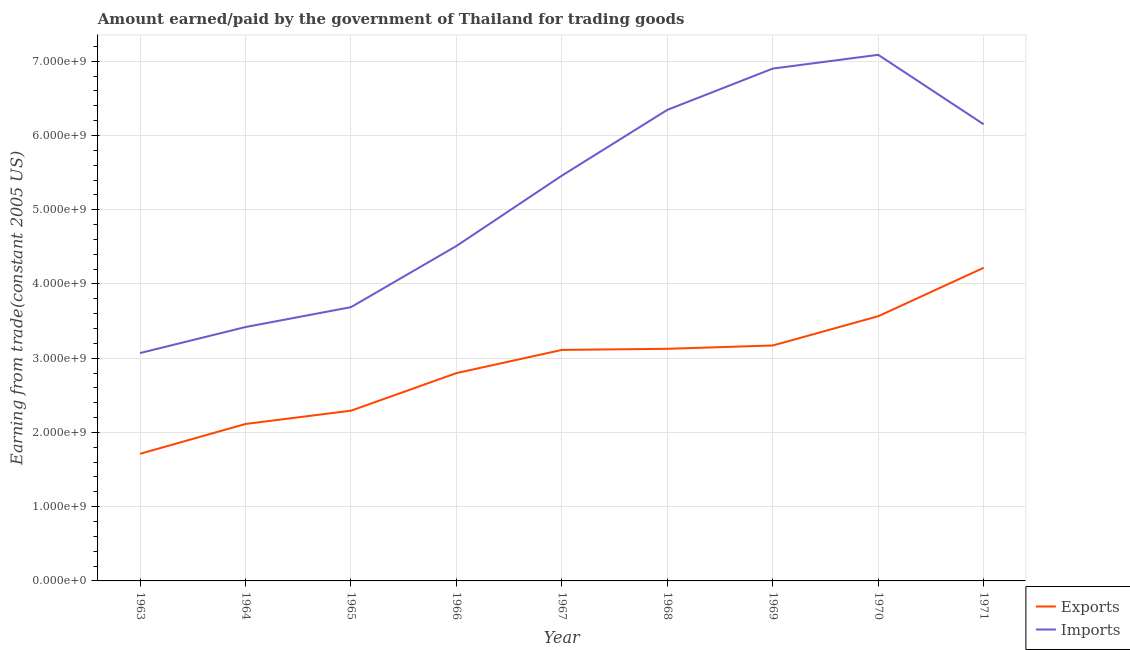Does the line corresponding to amount paid for imports intersect with the line corresponding to amount earned from exports?
Ensure brevity in your answer.  No. What is the amount earned from exports in 1967?
Offer a very short reply. 3.11e+09. Across all years, what is the maximum amount paid for imports?
Make the answer very short. 7.09e+09. Across all years, what is the minimum amount earned from exports?
Your answer should be compact. 1.71e+09. What is the total amount earned from exports in the graph?
Offer a terse response. 2.61e+1. What is the difference between the amount paid for imports in 1965 and that in 1969?
Your response must be concise. -3.21e+09. What is the difference between the amount paid for imports in 1966 and the amount earned from exports in 1969?
Provide a succinct answer. 1.34e+09. What is the average amount earned from exports per year?
Your answer should be very brief. 2.90e+09. In the year 1963, what is the difference between the amount paid for imports and amount earned from exports?
Offer a terse response. 1.36e+09. In how many years, is the amount paid for imports greater than 1800000000 US$?
Offer a terse response. 9. What is the ratio of the amount earned from exports in 1964 to that in 1970?
Give a very brief answer. 0.59. Is the amount paid for imports in 1966 less than that in 1970?
Provide a short and direct response. Yes. What is the difference between the highest and the second highest amount earned from exports?
Your answer should be compact. 6.53e+08. What is the difference between the highest and the lowest amount earned from exports?
Give a very brief answer. 2.51e+09. In how many years, is the amount earned from exports greater than the average amount earned from exports taken over all years?
Your answer should be very brief. 5. Does the amount paid for imports monotonically increase over the years?
Offer a terse response. No. What is the difference between two consecutive major ticks on the Y-axis?
Provide a short and direct response. 1.00e+09. Are the values on the major ticks of Y-axis written in scientific E-notation?
Your answer should be very brief. Yes. Does the graph contain any zero values?
Make the answer very short. No. Where does the legend appear in the graph?
Keep it short and to the point. Bottom right. What is the title of the graph?
Your answer should be compact. Amount earned/paid by the government of Thailand for trading goods. What is the label or title of the X-axis?
Your answer should be compact. Year. What is the label or title of the Y-axis?
Your answer should be very brief. Earning from trade(constant 2005 US). What is the Earning from trade(constant 2005 US) in Exports in 1963?
Your response must be concise. 1.71e+09. What is the Earning from trade(constant 2005 US) of Imports in 1963?
Your response must be concise. 3.07e+09. What is the Earning from trade(constant 2005 US) of Exports in 1964?
Your answer should be very brief. 2.11e+09. What is the Earning from trade(constant 2005 US) of Imports in 1964?
Your response must be concise. 3.42e+09. What is the Earning from trade(constant 2005 US) in Exports in 1965?
Keep it short and to the point. 2.29e+09. What is the Earning from trade(constant 2005 US) of Imports in 1965?
Make the answer very short. 3.69e+09. What is the Earning from trade(constant 2005 US) in Exports in 1966?
Give a very brief answer. 2.80e+09. What is the Earning from trade(constant 2005 US) in Imports in 1966?
Offer a terse response. 4.51e+09. What is the Earning from trade(constant 2005 US) in Exports in 1967?
Make the answer very short. 3.11e+09. What is the Earning from trade(constant 2005 US) of Imports in 1967?
Give a very brief answer. 5.46e+09. What is the Earning from trade(constant 2005 US) of Exports in 1968?
Ensure brevity in your answer.  3.13e+09. What is the Earning from trade(constant 2005 US) of Imports in 1968?
Offer a terse response. 6.34e+09. What is the Earning from trade(constant 2005 US) in Exports in 1969?
Give a very brief answer. 3.17e+09. What is the Earning from trade(constant 2005 US) in Imports in 1969?
Your answer should be compact. 6.90e+09. What is the Earning from trade(constant 2005 US) in Exports in 1970?
Your answer should be compact. 3.57e+09. What is the Earning from trade(constant 2005 US) of Imports in 1970?
Keep it short and to the point. 7.09e+09. What is the Earning from trade(constant 2005 US) of Exports in 1971?
Provide a short and direct response. 4.22e+09. What is the Earning from trade(constant 2005 US) of Imports in 1971?
Your response must be concise. 6.15e+09. Across all years, what is the maximum Earning from trade(constant 2005 US) of Exports?
Your answer should be compact. 4.22e+09. Across all years, what is the maximum Earning from trade(constant 2005 US) in Imports?
Offer a terse response. 7.09e+09. Across all years, what is the minimum Earning from trade(constant 2005 US) in Exports?
Your response must be concise. 1.71e+09. Across all years, what is the minimum Earning from trade(constant 2005 US) in Imports?
Your answer should be very brief. 3.07e+09. What is the total Earning from trade(constant 2005 US) of Exports in the graph?
Give a very brief answer. 2.61e+1. What is the total Earning from trade(constant 2005 US) in Imports in the graph?
Your answer should be very brief. 4.66e+1. What is the difference between the Earning from trade(constant 2005 US) in Exports in 1963 and that in 1964?
Make the answer very short. -4.02e+08. What is the difference between the Earning from trade(constant 2005 US) in Imports in 1963 and that in 1964?
Provide a succinct answer. -3.50e+08. What is the difference between the Earning from trade(constant 2005 US) in Exports in 1963 and that in 1965?
Give a very brief answer. -5.81e+08. What is the difference between the Earning from trade(constant 2005 US) of Imports in 1963 and that in 1965?
Your answer should be very brief. -6.18e+08. What is the difference between the Earning from trade(constant 2005 US) in Exports in 1963 and that in 1966?
Provide a short and direct response. -1.09e+09. What is the difference between the Earning from trade(constant 2005 US) in Imports in 1963 and that in 1966?
Offer a terse response. -1.44e+09. What is the difference between the Earning from trade(constant 2005 US) of Exports in 1963 and that in 1967?
Make the answer very short. -1.40e+09. What is the difference between the Earning from trade(constant 2005 US) in Imports in 1963 and that in 1967?
Provide a succinct answer. -2.39e+09. What is the difference between the Earning from trade(constant 2005 US) in Exports in 1963 and that in 1968?
Give a very brief answer. -1.41e+09. What is the difference between the Earning from trade(constant 2005 US) in Imports in 1963 and that in 1968?
Your answer should be very brief. -3.28e+09. What is the difference between the Earning from trade(constant 2005 US) of Exports in 1963 and that in 1969?
Make the answer very short. -1.46e+09. What is the difference between the Earning from trade(constant 2005 US) of Imports in 1963 and that in 1969?
Your response must be concise. -3.83e+09. What is the difference between the Earning from trade(constant 2005 US) of Exports in 1963 and that in 1970?
Offer a terse response. -1.85e+09. What is the difference between the Earning from trade(constant 2005 US) in Imports in 1963 and that in 1970?
Provide a short and direct response. -4.02e+09. What is the difference between the Earning from trade(constant 2005 US) in Exports in 1963 and that in 1971?
Provide a succinct answer. -2.51e+09. What is the difference between the Earning from trade(constant 2005 US) in Imports in 1963 and that in 1971?
Offer a very short reply. -3.08e+09. What is the difference between the Earning from trade(constant 2005 US) of Exports in 1964 and that in 1965?
Ensure brevity in your answer.  -1.79e+08. What is the difference between the Earning from trade(constant 2005 US) in Imports in 1964 and that in 1965?
Offer a very short reply. -2.68e+08. What is the difference between the Earning from trade(constant 2005 US) in Exports in 1964 and that in 1966?
Give a very brief answer. -6.85e+08. What is the difference between the Earning from trade(constant 2005 US) of Imports in 1964 and that in 1966?
Provide a succinct answer. -1.09e+09. What is the difference between the Earning from trade(constant 2005 US) of Exports in 1964 and that in 1967?
Your answer should be compact. -9.98e+08. What is the difference between the Earning from trade(constant 2005 US) in Imports in 1964 and that in 1967?
Provide a short and direct response. -2.04e+09. What is the difference between the Earning from trade(constant 2005 US) in Exports in 1964 and that in 1968?
Offer a very short reply. -1.01e+09. What is the difference between the Earning from trade(constant 2005 US) of Imports in 1964 and that in 1968?
Your answer should be compact. -2.93e+09. What is the difference between the Earning from trade(constant 2005 US) of Exports in 1964 and that in 1969?
Keep it short and to the point. -1.06e+09. What is the difference between the Earning from trade(constant 2005 US) of Imports in 1964 and that in 1969?
Your response must be concise. -3.48e+09. What is the difference between the Earning from trade(constant 2005 US) in Exports in 1964 and that in 1970?
Offer a terse response. -1.45e+09. What is the difference between the Earning from trade(constant 2005 US) in Imports in 1964 and that in 1970?
Ensure brevity in your answer.  -3.67e+09. What is the difference between the Earning from trade(constant 2005 US) in Exports in 1964 and that in 1971?
Your answer should be very brief. -2.10e+09. What is the difference between the Earning from trade(constant 2005 US) in Imports in 1964 and that in 1971?
Give a very brief answer. -2.73e+09. What is the difference between the Earning from trade(constant 2005 US) of Exports in 1965 and that in 1966?
Provide a succinct answer. -5.06e+08. What is the difference between the Earning from trade(constant 2005 US) of Imports in 1965 and that in 1966?
Your answer should be very brief. -8.24e+08. What is the difference between the Earning from trade(constant 2005 US) in Exports in 1965 and that in 1967?
Provide a short and direct response. -8.19e+08. What is the difference between the Earning from trade(constant 2005 US) of Imports in 1965 and that in 1967?
Your answer should be very brief. -1.77e+09. What is the difference between the Earning from trade(constant 2005 US) of Exports in 1965 and that in 1968?
Your answer should be compact. -8.34e+08. What is the difference between the Earning from trade(constant 2005 US) in Imports in 1965 and that in 1968?
Your answer should be compact. -2.66e+09. What is the difference between the Earning from trade(constant 2005 US) of Exports in 1965 and that in 1969?
Keep it short and to the point. -8.78e+08. What is the difference between the Earning from trade(constant 2005 US) of Imports in 1965 and that in 1969?
Your response must be concise. -3.21e+09. What is the difference between the Earning from trade(constant 2005 US) of Exports in 1965 and that in 1970?
Your answer should be compact. -1.27e+09. What is the difference between the Earning from trade(constant 2005 US) in Imports in 1965 and that in 1970?
Your answer should be compact. -3.40e+09. What is the difference between the Earning from trade(constant 2005 US) of Exports in 1965 and that in 1971?
Offer a very short reply. -1.93e+09. What is the difference between the Earning from trade(constant 2005 US) in Imports in 1965 and that in 1971?
Your answer should be compact. -2.46e+09. What is the difference between the Earning from trade(constant 2005 US) of Exports in 1966 and that in 1967?
Offer a very short reply. -3.13e+08. What is the difference between the Earning from trade(constant 2005 US) of Imports in 1966 and that in 1967?
Your response must be concise. -9.48e+08. What is the difference between the Earning from trade(constant 2005 US) of Exports in 1966 and that in 1968?
Your answer should be compact. -3.28e+08. What is the difference between the Earning from trade(constant 2005 US) of Imports in 1966 and that in 1968?
Your answer should be very brief. -1.83e+09. What is the difference between the Earning from trade(constant 2005 US) of Exports in 1966 and that in 1969?
Provide a succinct answer. -3.72e+08. What is the difference between the Earning from trade(constant 2005 US) in Imports in 1966 and that in 1969?
Give a very brief answer. -2.39e+09. What is the difference between the Earning from trade(constant 2005 US) of Exports in 1966 and that in 1970?
Make the answer very short. -7.67e+08. What is the difference between the Earning from trade(constant 2005 US) of Imports in 1966 and that in 1970?
Ensure brevity in your answer.  -2.57e+09. What is the difference between the Earning from trade(constant 2005 US) in Exports in 1966 and that in 1971?
Keep it short and to the point. -1.42e+09. What is the difference between the Earning from trade(constant 2005 US) of Imports in 1966 and that in 1971?
Your response must be concise. -1.64e+09. What is the difference between the Earning from trade(constant 2005 US) of Exports in 1967 and that in 1968?
Make the answer very short. -1.49e+07. What is the difference between the Earning from trade(constant 2005 US) in Imports in 1967 and that in 1968?
Provide a short and direct response. -8.86e+08. What is the difference between the Earning from trade(constant 2005 US) in Exports in 1967 and that in 1969?
Provide a succinct answer. -5.95e+07. What is the difference between the Earning from trade(constant 2005 US) in Imports in 1967 and that in 1969?
Your response must be concise. -1.44e+09. What is the difference between the Earning from trade(constant 2005 US) in Exports in 1967 and that in 1970?
Offer a terse response. -4.54e+08. What is the difference between the Earning from trade(constant 2005 US) of Imports in 1967 and that in 1970?
Provide a succinct answer. -1.63e+09. What is the difference between the Earning from trade(constant 2005 US) of Exports in 1967 and that in 1971?
Ensure brevity in your answer.  -1.11e+09. What is the difference between the Earning from trade(constant 2005 US) of Imports in 1967 and that in 1971?
Offer a terse response. -6.91e+08. What is the difference between the Earning from trade(constant 2005 US) of Exports in 1968 and that in 1969?
Provide a short and direct response. -4.47e+07. What is the difference between the Earning from trade(constant 2005 US) of Imports in 1968 and that in 1969?
Offer a very short reply. -5.56e+08. What is the difference between the Earning from trade(constant 2005 US) in Exports in 1968 and that in 1970?
Your answer should be very brief. -4.39e+08. What is the difference between the Earning from trade(constant 2005 US) in Imports in 1968 and that in 1970?
Give a very brief answer. -7.41e+08. What is the difference between the Earning from trade(constant 2005 US) in Exports in 1968 and that in 1971?
Keep it short and to the point. -1.09e+09. What is the difference between the Earning from trade(constant 2005 US) of Imports in 1968 and that in 1971?
Your response must be concise. 1.95e+08. What is the difference between the Earning from trade(constant 2005 US) of Exports in 1969 and that in 1970?
Provide a short and direct response. -3.94e+08. What is the difference between the Earning from trade(constant 2005 US) in Imports in 1969 and that in 1970?
Provide a succinct answer. -1.85e+08. What is the difference between the Earning from trade(constant 2005 US) in Exports in 1969 and that in 1971?
Ensure brevity in your answer.  -1.05e+09. What is the difference between the Earning from trade(constant 2005 US) in Imports in 1969 and that in 1971?
Offer a terse response. 7.51e+08. What is the difference between the Earning from trade(constant 2005 US) in Exports in 1970 and that in 1971?
Your response must be concise. -6.53e+08. What is the difference between the Earning from trade(constant 2005 US) of Imports in 1970 and that in 1971?
Offer a very short reply. 9.36e+08. What is the difference between the Earning from trade(constant 2005 US) in Exports in 1963 and the Earning from trade(constant 2005 US) in Imports in 1964?
Give a very brief answer. -1.71e+09. What is the difference between the Earning from trade(constant 2005 US) of Exports in 1963 and the Earning from trade(constant 2005 US) of Imports in 1965?
Your answer should be compact. -1.98e+09. What is the difference between the Earning from trade(constant 2005 US) in Exports in 1963 and the Earning from trade(constant 2005 US) in Imports in 1966?
Your response must be concise. -2.80e+09. What is the difference between the Earning from trade(constant 2005 US) of Exports in 1963 and the Earning from trade(constant 2005 US) of Imports in 1967?
Provide a short and direct response. -3.75e+09. What is the difference between the Earning from trade(constant 2005 US) of Exports in 1963 and the Earning from trade(constant 2005 US) of Imports in 1968?
Offer a very short reply. -4.63e+09. What is the difference between the Earning from trade(constant 2005 US) in Exports in 1963 and the Earning from trade(constant 2005 US) in Imports in 1969?
Your answer should be very brief. -5.19e+09. What is the difference between the Earning from trade(constant 2005 US) in Exports in 1963 and the Earning from trade(constant 2005 US) in Imports in 1970?
Provide a short and direct response. -5.37e+09. What is the difference between the Earning from trade(constant 2005 US) in Exports in 1963 and the Earning from trade(constant 2005 US) in Imports in 1971?
Offer a terse response. -4.44e+09. What is the difference between the Earning from trade(constant 2005 US) in Exports in 1964 and the Earning from trade(constant 2005 US) in Imports in 1965?
Your response must be concise. -1.57e+09. What is the difference between the Earning from trade(constant 2005 US) of Exports in 1964 and the Earning from trade(constant 2005 US) of Imports in 1966?
Your response must be concise. -2.40e+09. What is the difference between the Earning from trade(constant 2005 US) in Exports in 1964 and the Earning from trade(constant 2005 US) in Imports in 1967?
Provide a short and direct response. -3.34e+09. What is the difference between the Earning from trade(constant 2005 US) of Exports in 1964 and the Earning from trade(constant 2005 US) of Imports in 1968?
Offer a very short reply. -4.23e+09. What is the difference between the Earning from trade(constant 2005 US) in Exports in 1964 and the Earning from trade(constant 2005 US) in Imports in 1969?
Keep it short and to the point. -4.79e+09. What is the difference between the Earning from trade(constant 2005 US) of Exports in 1964 and the Earning from trade(constant 2005 US) of Imports in 1970?
Ensure brevity in your answer.  -4.97e+09. What is the difference between the Earning from trade(constant 2005 US) in Exports in 1964 and the Earning from trade(constant 2005 US) in Imports in 1971?
Make the answer very short. -4.04e+09. What is the difference between the Earning from trade(constant 2005 US) in Exports in 1965 and the Earning from trade(constant 2005 US) in Imports in 1966?
Your answer should be compact. -2.22e+09. What is the difference between the Earning from trade(constant 2005 US) in Exports in 1965 and the Earning from trade(constant 2005 US) in Imports in 1967?
Offer a terse response. -3.17e+09. What is the difference between the Earning from trade(constant 2005 US) in Exports in 1965 and the Earning from trade(constant 2005 US) in Imports in 1968?
Give a very brief answer. -4.05e+09. What is the difference between the Earning from trade(constant 2005 US) of Exports in 1965 and the Earning from trade(constant 2005 US) of Imports in 1969?
Your answer should be compact. -4.61e+09. What is the difference between the Earning from trade(constant 2005 US) in Exports in 1965 and the Earning from trade(constant 2005 US) in Imports in 1970?
Make the answer very short. -4.79e+09. What is the difference between the Earning from trade(constant 2005 US) of Exports in 1965 and the Earning from trade(constant 2005 US) of Imports in 1971?
Your answer should be compact. -3.86e+09. What is the difference between the Earning from trade(constant 2005 US) of Exports in 1966 and the Earning from trade(constant 2005 US) of Imports in 1967?
Make the answer very short. -2.66e+09. What is the difference between the Earning from trade(constant 2005 US) of Exports in 1966 and the Earning from trade(constant 2005 US) of Imports in 1968?
Ensure brevity in your answer.  -3.55e+09. What is the difference between the Earning from trade(constant 2005 US) of Exports in 1966 and the Earning from trade(constant 2005 US) of Imports in 1969?
Ensure brevity in your answer.  -4.10e+09. What is the difference between the Earning from trade(constant 2005 US) in Exports in 1966 and the Earning from trade(constant 2005 US) in Imports in 1970?
Your answer should be compact. -4.29e+09. What is the difference between the Earning from trade(constant 2005 US) in Exports in 1966 and the Earning from trade(constant 2005 US) in Imports in 1971?
Ensure brevity in your answer.  -3.35e+09. What is the difference between the Earning from trade(constant 2005 US) in Exports in 1967 and the Earning from trade(constant 2005 US) in Imports in 1968?
Ensure brevity in your answer.  -3.23e+09. What is the difference between the Earning from trade(constant 2005 US) in Exports in 1967 and the Earning from trade(constant 2005 US) in Imports in 1969?
Offer a very short reply. -3.79e+09. What is the difference between the Earning from trade(constant 2005 US) in Exports in 1967 and the Earning from trade(constant 2005 US) in Imports in 1970?
Your response must be concise. -3.97e+09. What is the difference between the Earning from trade(constant 2005 US) of Exports in 1967 and the Earning from trade(constant 2005 US) of Imports in 1971?
Your answer should be very brief. -3.04e+09. What is the difference between the Earning from trade(constant 2005 US) in Exports in 1968 and the Earning from trade(constant 2005 US) in Imports in 1969?
Make the answer very short. -3.77e+09. What is the difference between the Earning from trade(constant 2005 US) in Exports in 1968 and the Earning from trade(constant 2005 US) in Imports in 1970?
Keep it short and to the point. -3.96e+09. What is the difference between the Earning from trade(constant 2005 US) of Exports in 1968 and the Earning from trade(constant 2005 US) of Imports in 1971?
Offer a terse response. -3.02e+09. What is the difference between the Earning from trade(constant 2005 US) of Exports in 1969 and the Earning from trade(constant 2005 US) of Imports in 1970?
Make the answer very short. -3.92e+09. What is the difference between the Earning from trade(constant 2005 US) of Exports in 1969 and the Earning from trade(constant 2005 US) of Imports in 1971?
Your answer should be compact. -2.98e+09. What is the difference between the Earning from trade(constant 2005 US) in Exports in 1970 and the Earning from trade(constant 2005 US) in Imports in 1971?
Your response must be concise. -2.58e+09. What is the average Earning from trade(constant 2005 US) in Exports per year?
Give a very brief answer. 2.90e+09. What is the average Earning from trade(constant 2005 US) of Imports per year?
Make the answer very short. 5.18e+09. In the year 1963, what is the difference between the Earning from trade(constant 2005 US) in Exports and Earning from trade(constant 2005 US) in Imports?
Make the answer very short. -1.36e+09. In the year 1964, what is the difference between the Earning from trade(constant 2005 US) in Exports and Earning from trade(constant 2005 US) in Imports?
Your answer should be compact. -1.31e+09. In the year 1965, what is the difference between the Earning from trade(constant 2005 US) of Exports and Earning from trade(constant 2005 US) of Imports?
Make the answer very short. -1.39e+09. In the year 1966, what is the difference between the Earning from trade(constant 2005 US) in Exports and Earning from trade(constant 2005 US) in Imports?
Your response must be concise. -1.71e+09. In the year 1967, what is the difference between the Earning from trade(constant 2005 US) in Exports and Earning from trade(constant 2005 US) in Imports?
Provide a short and direct response. -2.35e+09. In the year 1968, what is the difference between the Earning from trade(constant 2005 US) in Exports and Earning from trade(constant 2005 US) in Imports?
Your response must be concise. -3.22e+09. In the year 1969, what is the difference between the Earning from trade(constant 2005 US) in Exports and Earning from trade(constant 2005 US) in Imports?
Offer a very short reply. -3.73e+09. In the year 1970, what is the difference between the Earning from trade(constant 2005 US) of Exports and Earning from trade(constant 2005 US) of Imports?
Your answer should be compact. -3.52e+09. In the year 1971, what is the difference between the Earning from trade(constant 2005 US) in Exports and Earning from trade(constant 2005 US) in Imports?
Keep it short and to the point. -1.93e+09. What is the ratio of the Earning from trade(constant 2005 US) in Exports in 1963 to that in 1964?
Make the answer very short. 0.81. What is the ratio of the Earning from trade(constant 2005 US) of Imports in 1963 to that in 1964?
Provide a short and direct response. 0.9. What is the ratio of the Earning from trade(constant 2005 US) of Exports in 1963 to that in 1965?
Offer a very short reply. 0.75. What is the ratio of the Earning from trade(constant 2005 US) in Imports in 1963 to that in 1965?
Your response must be concise. 0.83. What is the ratio of the Earning from trade(constant 2005 US) in Exports in 1963 to that in 1966?
Your response must be concise. 0.61. What is the ratio of the Earning from trade(constant 2005 US) of Imports in 1963 to that in 1966?
Ensure brevity in your answer.  0.68. What is the ratio of the Earning from trade(constant 2005 US) of Exports in 1963 to that in 1967?
Offer a very short reply. 0.55. What is the ratio of the Earning from trade(constant 2005 US) of Imports in 1963 to that in 1967?
Offer a very short reply. 0.56. What is the ratio of the Earning from trade(constant 2005 US) in Exports in 1963 to that in 1968?
Give a very brief answer. 0.55. What is the ratio of the Earning from trade(constant 2005 US) of Imports in 1963 to that in 1968?
Your answer should be compact. 0.48. What is the ratio of the Earning from trade(constant 2005 US) of Exports in 1963 to that in 1969?
Your response must be concise. 0.54. What is the ratio of the Earning from trade(constant 2005 US) in Imports in 1963 to that in 1969?
Provide a short and direct response. 0.44. What is the ratio of the Earning from trade(constant 2005 US) in Exports in 1963 to that in 1970?
Your answer should be compact. 0.48. What is the ratio of the Earning from trade(constant 2005 US) in Imports in 1963 to that in 1970?
Provide a succinct answer. 0.43. What is the ratio of the Earning from trade(constant 2005 US) of Exports in 1963 to that in 1971?
Your response must be concise. 0.41. What is the ratio of the Earning from trade(constant 2005 US) of Imports in 1963 to that in 1971?
Offer a terse response. 0.5. What is the ratio of the Earning from trade(constant 2005 US) in Exports in 1964 to that in 1965?
Your answer should be very brief. 0.92. What is the ratio of the Earning from trade(constant 2005 US) of Imports in 1964 to that in 1965?
Offer a terse response. 0.93. What is the ratio of the Earning from trade(constant 2005 US) in Exports in 1964 to that in 1966?
Ensure brevity in your answer.  0.76. What is the ratio of the Earning from trade(constant 2005 US) in Imports in 1964 to that in 1966?
Your answer should be very brief. 0.76. What is the ratio of the Earning from trade(constant 2005 US) of Exports in 1964 to that in 1967?
Your answer should be very brief. 0.68. What is the ratio of the Earning from trade(constant 2005 US) in Imports in 1964 to that in 1967?
Provide a short and direct response. 0.63. What is the ratio of the Earning from trade(constant 2005 US) of Exports in 1964 to that in 1968?
Give a very brief answer. 0.68. What is the ratio of the Earning from trade(constant 2005 US) in Imports in 1964 to that in 1968?
Your answer should be compact. 0.54. What is the ratio of the Earning from trade(constant 2005 US) in Imports in 1964 to that in 1969?
Make the answer very short. 0.5. What is the ratio of the Earning from trade(constant 2005 US) of Exports in 1964 to that in 1970?
Keep it short and to the point. 0.59. What is the ratio of the Earning from trade(constant 2005 US) of Imports in 1964 to that in 1970?
Offer a terse response. 0.48. What is the ratio of the Earning from trade(constant 2005 US) in Exports in 1964 to that in 1971?
Make the answer very short. 0.5. What is the ratio of the Earning from trade(constant 2005 US) in Imports in 1964 to that in 1971?
Give a very brief answer. 0.56. What is the ratio of the Earning from trade(constant 2005 US) of Exports in 1965 to that in 1966?
Keep it short and to the point. 0.82. What is the ratio of the Earning from trade(constant 2005 US) in Imports in 1965 to that in 1966?
Keep it short and to the point. 0.82. What is the ratio of the Earning from trade(constant 2005 US) of Exports in 1965 to that in 1967?
Provide a succinct answer. 0.74. What is the ratio of the Earning from trade(constant 2005 US) in Imports in 1965 to that in 1967?
Keep it short and to the point. 0.68. What is the ratio of the Earning from trade(constant 2005 US) in Exports in 1965 to that in 1968?
Make the answer very short. 0.73. What is the ratio of the Earning from trade(constant 2005 US) of Imports in 1965 to that in 1968?
Give a very brief answer. 0.58. What is the ratio of the Earning from trade(constant 2005 US) in Exports in 1965 to that in 1969?
Offer a terse response. 0.72. What is the ratio of the Earning from trade(constant 2005 US) in Imports in 1965 to that in 1969?
Provide a succinct answer. 0.53. What is the ratio of the Earning from trade(constant 2005 US) in Exports in 1965 to that in 1970?
Your response must be concise. 0.64. What is the ratio of the Earning from trade(constant 2005 US) of Imports in 1965 to that in 1970?
Offer a terse response. 0.52. What is the ratio of the Earning from trade(constant 2005 US) of Exports in 1965 to that in 1971?
Your answer should be compact. 0.54. What is the ratio of the Earning from trade(constant 2005 US) in Imports in 1965 to that in 1971?
Make the answer very short. 0.6. What is the ratio of the Earning from trade(constant 2005 US) in Exports in 1966 to that in 1967?
Offer a very short reply. 0.9. What is the ratio of the Earning from trade(constant 2005 US) in Imports in 1966 to that in 1967?
Your response must be concise. 0.83. What is the ratio of the Earning from trade(constant 2005 US) of Exports in 1966 to that in 1968?
Offer a terse response. 0.9. What is the ratio of the Earning from trade(constant 2005 US) of Imports in 1966 to that in 1968?
Your answer should be compact. 0.71. What is the ratio of the Earning from trade(constant 2005 US) in Exports in 1966 to that in 1969?
Ensure brevity in your answer.  0.88. What is the ratio of the Earning from trade(constant 2005 US) of Imports in 1966 to that in 1969?
Offer a very short reply. 0.65. What is the ratio of the Earning from trade(constant 2005 US) of Exports in 1966 to that in 1970?
Offer a very short reply. 0.79. What is the ratio of the Earning from trade(constant 2005 US) in Imports in 1966 to that in 1970?
Give a very brief answer. 0.64. What is the ratio of the Earning from trade(constant 2005 US) of Exports in 1966 to that in 1971?
Make the answer very short. 0.66. What is the ratio of the Earning from trade(constant 2005 US) of Imports in 1966 to that in 1971?
Your answer should be compact. 0.73. What is the ratio of the Earning from trade(constant 2005 US) of Imports in 1967 to that in 1968?
Your response must be concise. 0.86. What is the ratio of the Earning from trade(constant 2005 US) of Exports in 1967 to that in 1969?
Provide a succinct answer. 0.98. What is the ratio of the Earning from trade(constant 2005 US) in Imports in 1967 to that in 1969?
Provide a short and direct response. 0.79. What is the ratio of the Earning from trade(constant 2005 US) in Exports in 1967 to that in 1970?
Your answer should be very brief. 0.87. What is the ratio of the Earning from trade(constant 2005 US) in Imports in 1967 to that in 1970?
Offer a terse response. 0.77. What is the ratio of the Earning from trade(constant 2005 US) of Exports in 1967 to that in 1971?
Offer a very short reply. 0.74. What is the ratio of the Earning from trade(constant 2005 US) of Imports in 1967 to that in 1971?
Your response must be concise. 0.89. What is the ratio of the Earning from trade(constant 2005 US) in Exports in 1968 to that in 1969?
Ensure brevity in your answer.  0.99. What is the ratio of the Earning from trade(constant 2005 US) in Imports in 1968 to that in 1969?
Your answer should be very brief. 0.92. What is the ratio of the Earning from trade(constant 2005 US) in Exports in 1968 to that in 1970?
Your answer should be very brief. 0.88. What is the ratio of the Earning from trade(constant 2005 US) in Imports in 1968 to that in 1970?
Your response must be concise. 0.9. What is the ratio of the Earning from trade(constant 2005 US) in Exports in 1968 to that in 1971?
Your answer should be very brief. 0.74. What is the ratio of the Earning from trade(constant 2005 US) of Imports in 1968 to that in 1971?
Offer a very short reply. 1.03. What is the ratio of the Earning from trade(constant 2005 US) in Exports in 1969 to that in 1970?
Make the answer very short. 0.89. What is the ratio of the Earning from trade(constant 2005 US) of Imports in 1969 to that in 1970?
Ensure brevity in your answer.  0.97. What is the ratio of the Earning from trade(constant 2005 US) of Exports in 1969 to that in 1971?
Offer a very short reply. 0.75. What is the ratio of the Earning from trade(constant 2005 US) in Imports in 1969 to that in 1971?
Provide a succinct answer. 1.12. What is the ratio of the Earning from trade(constant 2005 US) in Exports in 1970 to that in 1971?
Your answer should be very brief. 0.85. What is the ratio of the Earning from trade(constant 2005 US) of Imports in 1970 to that in 1971?
Your response must be concise. 1.15. What is the difference between the highest and the second highest Earning from trade(constant 2005 US) of Exports?
Give a very brief answer. 6.53e+08. What is the difference between the highest and the second highest Earning from trade(constant 2005 US) of Imports?
Your answer should be very brief. 1.85e+08. What is the difference between the highest and the lowest Earning from trade(constant 2005 US) in Exports?
Provide a short and direct response. 2.51e+09. What is the difference between the highest and the lowest Earning from trade(constant 2005 US) in Imports?
Offer a very short reply. 4.02e+09. 